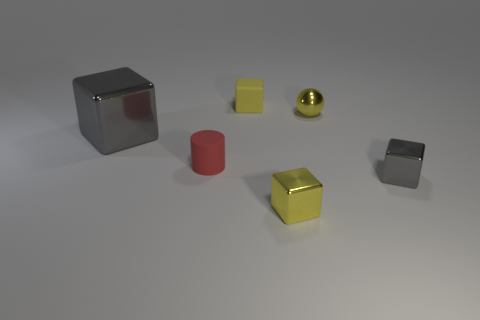There is a small rubber thing to the right of the red matte thing; does it have the same color as the large thing?
Your response must be concise. No. What size is the cube that is behind the gray metal thing to the left of the small matte cube?
Make the answer very short. Small. There is another gray cube that is the same size as the matte block; what is its material?
Your answer should be compact. Metal. How many other things are there of the same size as the cylinder?
Your response must be concise. 4. What number of cylinders are cyan matte things or small gray things?
Give a very brief answer. 0. Are there any other things that have the same material as the small gray object?
Provide a succinct answer. Yes. What material is the yellow object to the right of the small yellow cube that is in front of the tiny block that is right of the yellow metallic ball?
Your response must be concise. Metal. There is a small block that is the same color as the large shiny cube; what material is it?
Your answer should be compact. Metal. How many gray objects have the same material as the sphere?
Offer a terse response. 2. There is a block right of the shiny ball; is it the same size as the yellow ball?
Make the answer very short. Yes. 